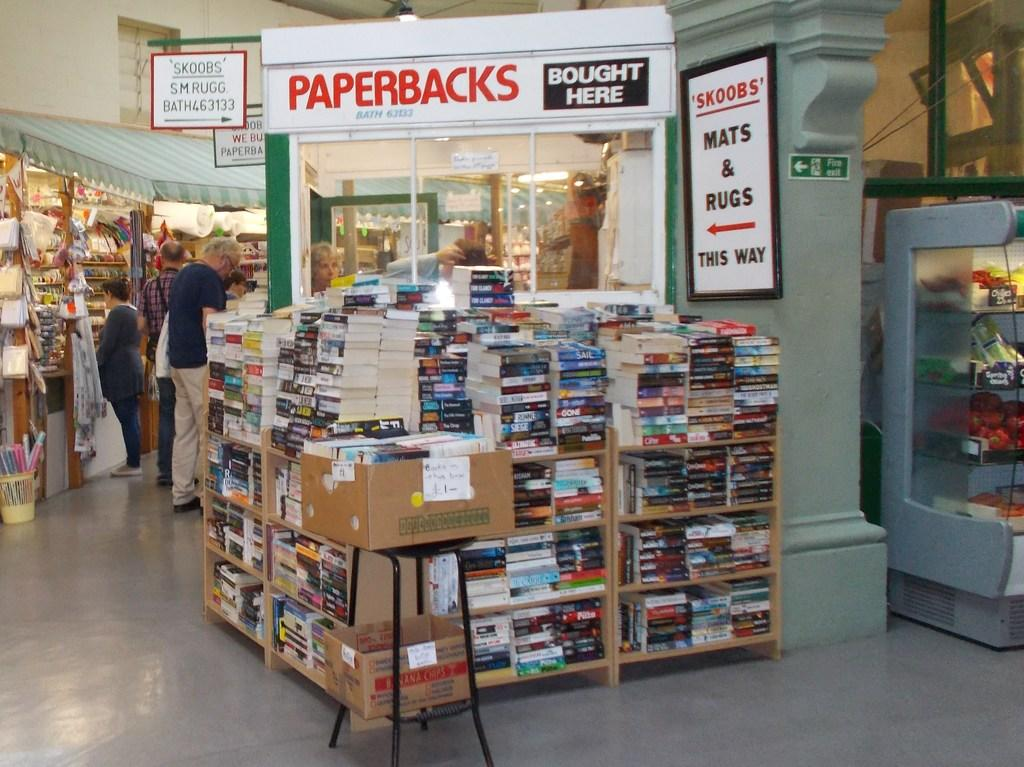Provide a one-sentence caption for the provided image. large stacks of books in front of paperbacks bought here sign. 